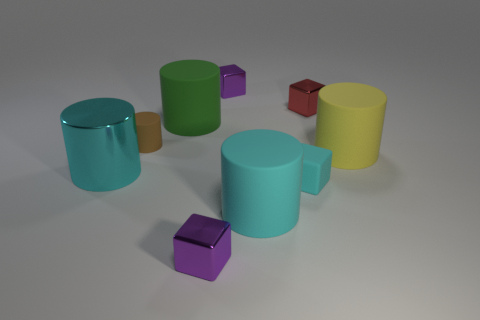Does the large metallic object have the same color as the small rubber thing on the right side of the green object?
Your answer should be very brief. Yes. What number of other objects are the same size as the yellow rubber cylinder?
Your response must be concise. 3. There is a metallic object that is the same color as the tiny rubber cube; what size is it?
Provide a succinct answer. Large. How many blocks are large cyan objects or cyan shiny things?
Ensure brevity in your answer.  0. Does the small rubber thing in front of the cyan shiny cylinder have the same shape as the green object?
Offer a terse response. No. Are there more small brown objects that are left of the big yellow cylinder than big gray metallic cylinders?
Your response must be concise. Yes. There is a matte block that is the same size as the red object; what color is it?
Your answer should be very brief. Cyan. How many objects are shiny objects behind the tiny cyan matte object or tiny yellow metal cubes?
Your answer should be compact. 3. The large matte thing that is the same color as the big shiny thing is what shape?
Offer a very short reply. Cylinder. There is a cylinder right of the block to the right of the tiny cyan matte object; what is its material?
Offer a terse response. Rubber. 